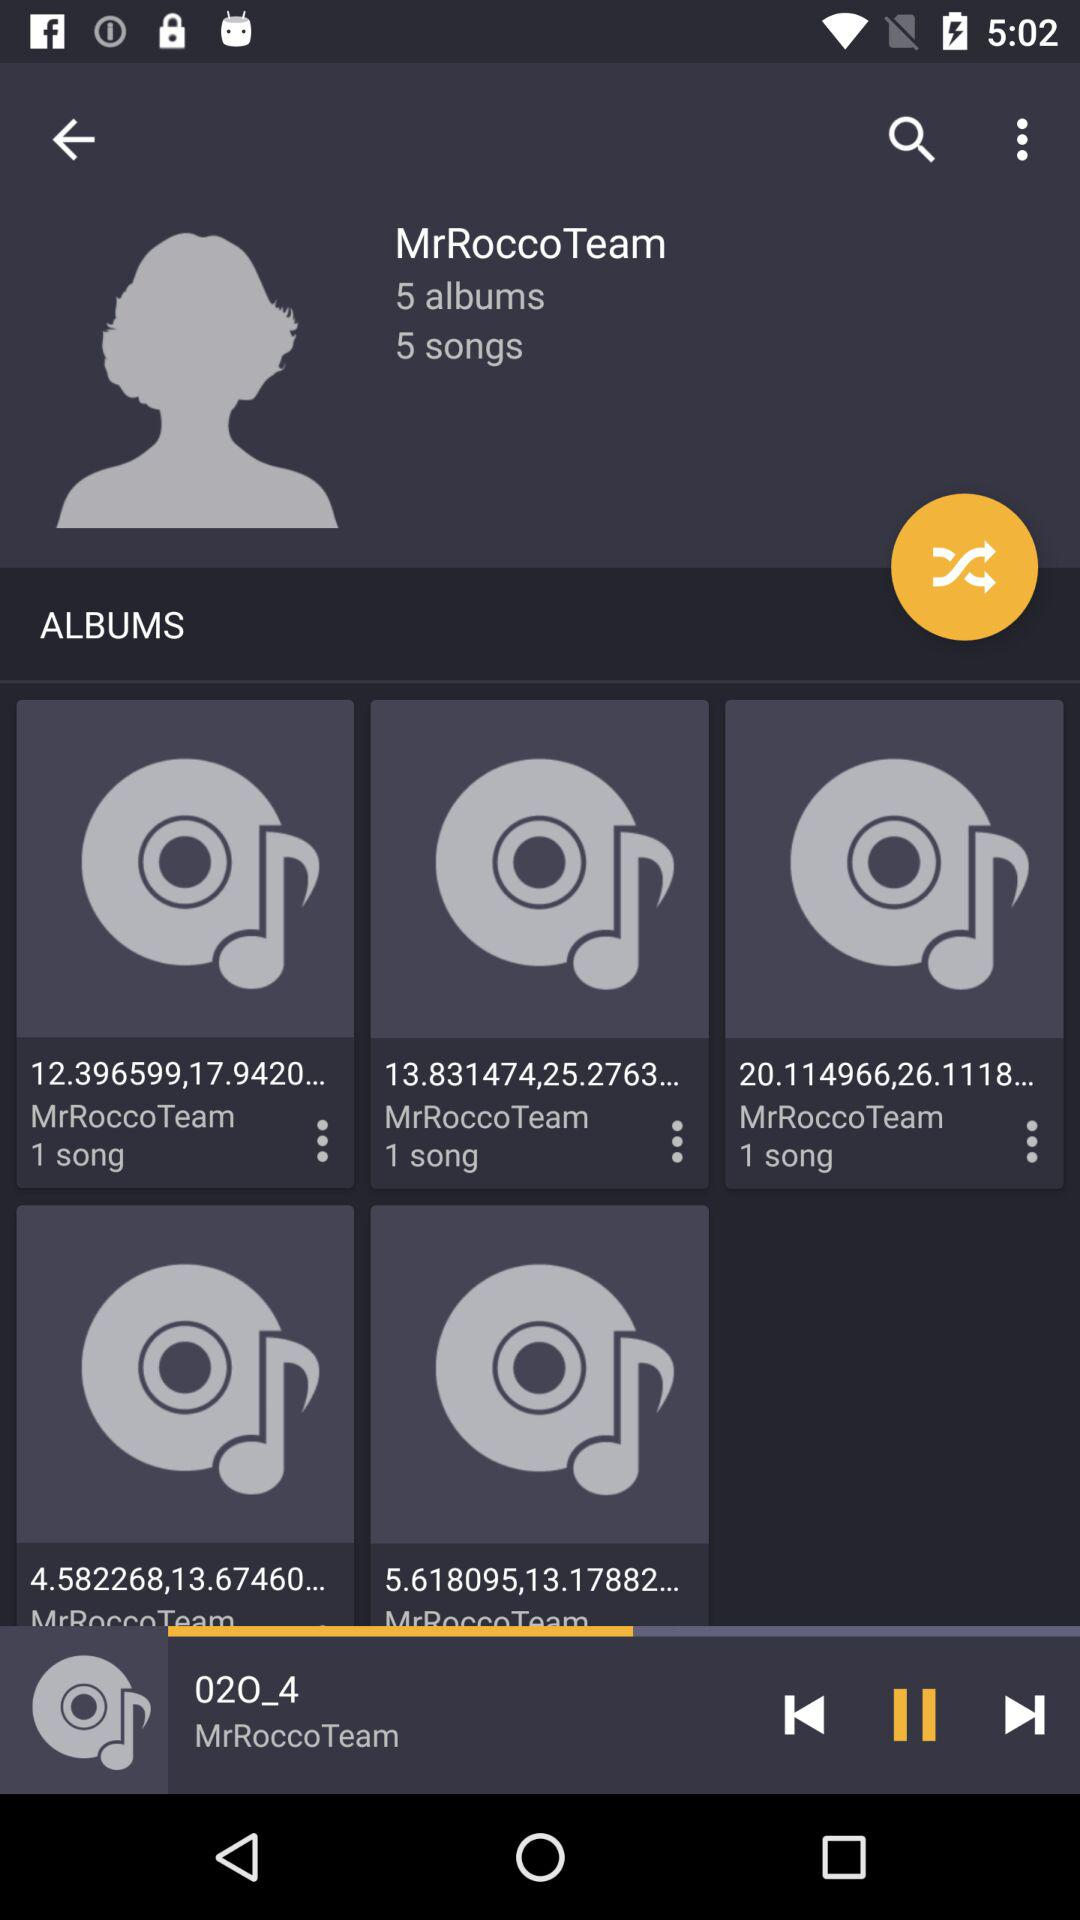How many albums are there? There are 5 albums. 